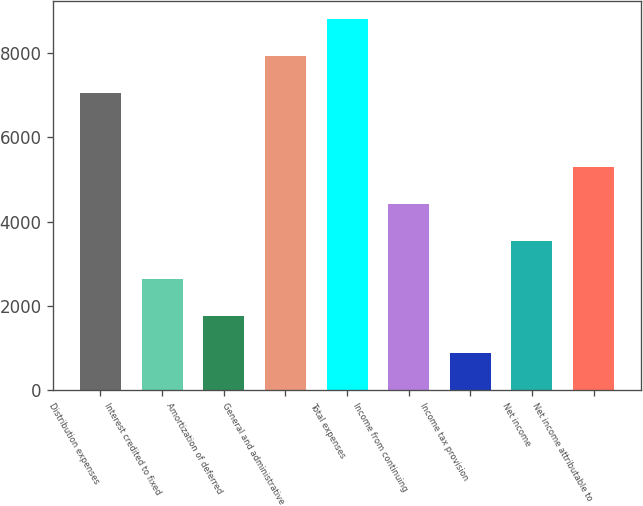<chart> <loc_0><loc_0><loc_500><loc_500><bar_chart><fcel>Distribution expenses<fcel>Interest credited to fixed<fcel>Amortization of deferred<fcel>General and administrative<fcel>Total expenses<fcel>Income from continuing<fcel>Income tax provision<fcel>Net income<fcel>Net income attributable to<nl><fcel>7046.44<fcel>2645.14<fcel>1764.88<fcel>7926.7<fcel>8807<fcel>4405.66<fcel>884.62<fcel>3525.4<fcel>5285.92<nl></chart> 